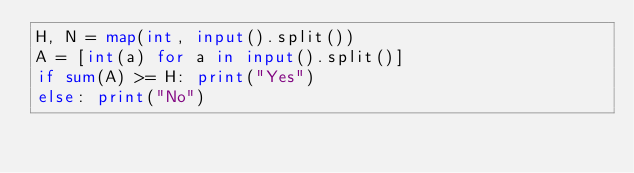Convert code to text. <code><loc_0><loc_0><loc_500><loc_500><_Python_>H, N = map(int, input().split())
A = [int(a) for a in input().split()]
if sum(A) >= H: print("Yes")
else: print("No")</code> 